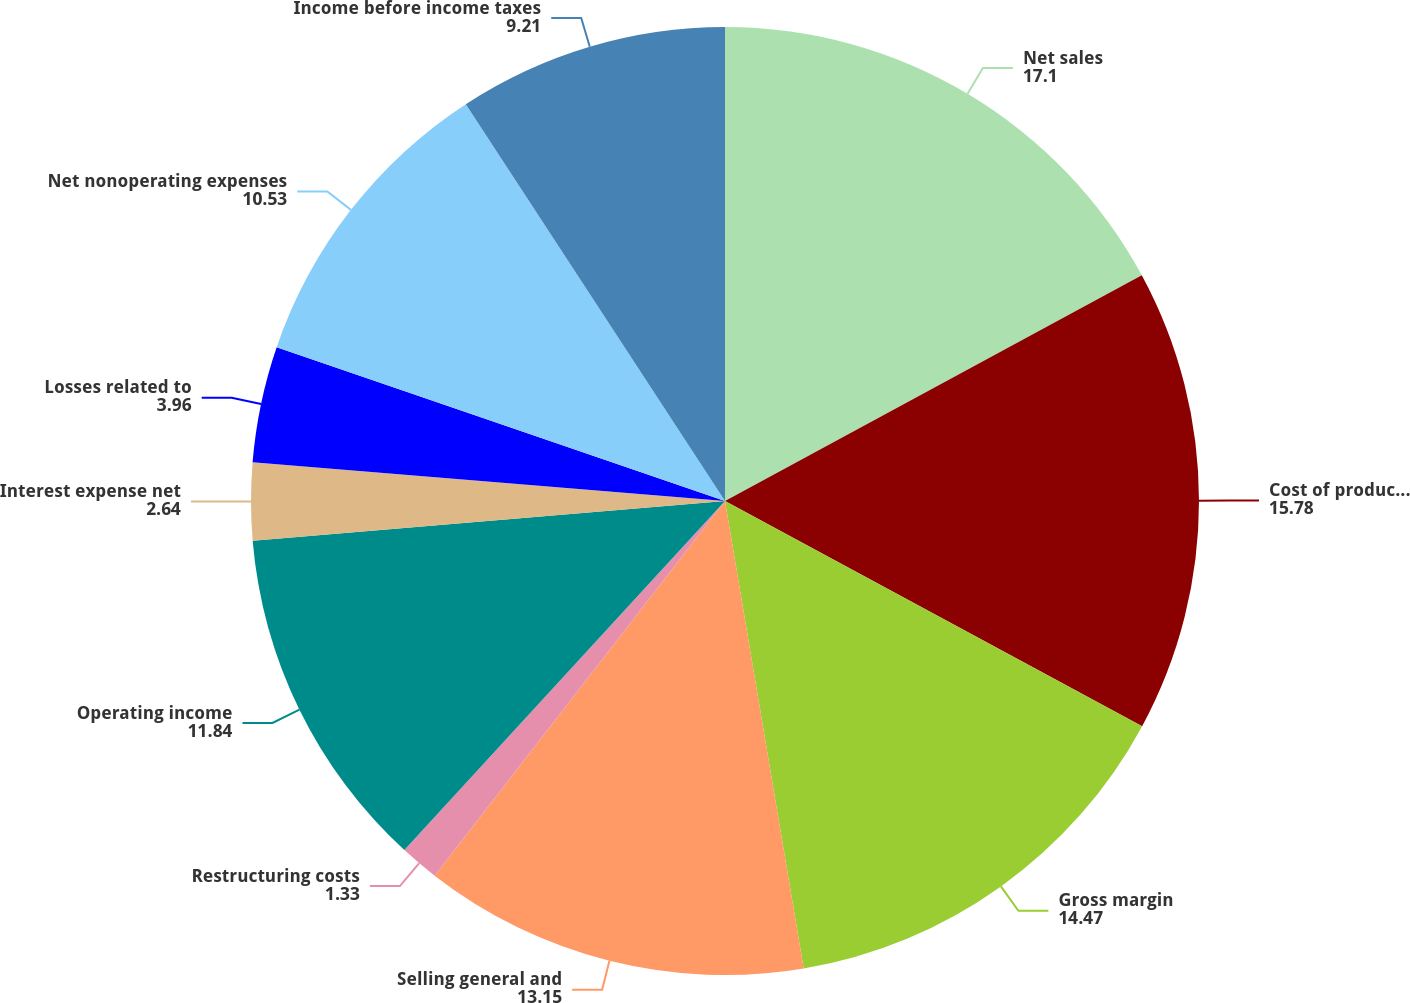Convert chart to OTSL. <chart><loc_0><loc_0><loc_500><loc_500><pie_chart><fcel>Net sales<fcel>Cost of products sold<fcel>Gross margin<fcel>Selling general and<fcel>Restructuring costs<fcel>Operating income<fcel>Interest expense net<fcel>Losses related to<fcel>Net nonoperating expenses<fcel>Income before income taxes<nl><fcel>17.1%<fcel>15.78%<fcel>14.47%<fcel>13.15%<fcel>1.33%<fcel>11.84%<fcel>2.64%<fcel>3.96%<fcel>10.53%<fcel>9.21%<nl></chart> 